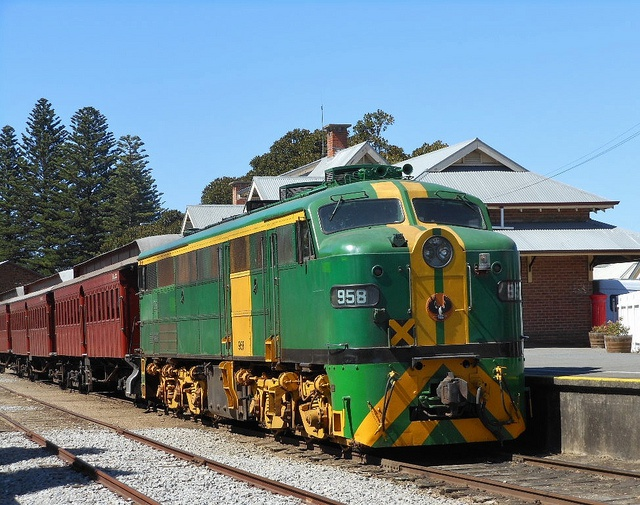Describe the objects in this image and their specific colors. I can see train in lightblue, black, gray, darkgreen, and maroon tones, potted plant in lightblue, gray, and black tones, and potted plant in lightblue, gray, maroon, and black tones in this image. 